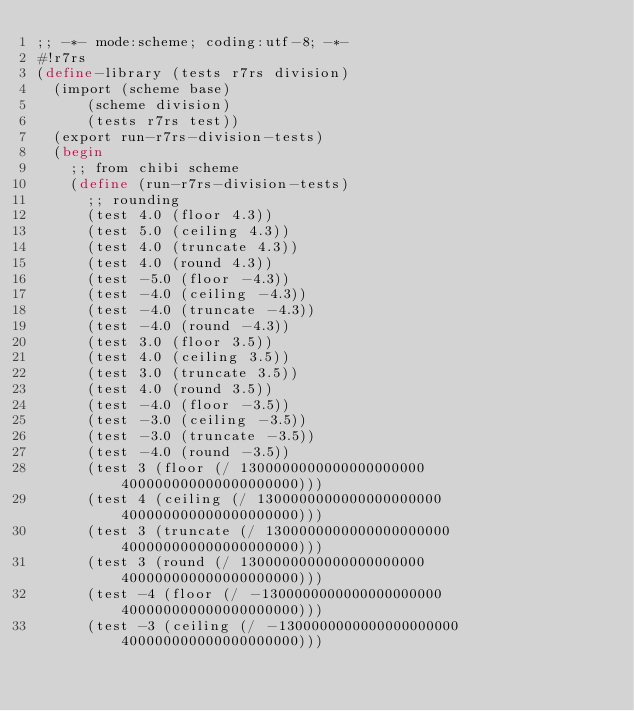Convert code to text. <code><loc_0><loc_0><loc_500><loc_500><_Scheme_>;; -*- mode:scheme; coding:utf-8; -*-
#!r7rs
(define-library (tests r7rs division)
  (import (scheme base)
	  (scheme division)
	  (tests r7rs test))
  (export run-r7rs-division-tests)
  (begin
    ;; from chibi scheme
    (define (run-r7rs-division-tests)
      ;; rounding
      (test 4.0 (floor 4.3))
      (test 5.0 (ceiling 4.3))
      (test 4.0 (truncate 4.3))
      (test 4.0 (round 4.3))
      (test -5.0 (floor -4.3))
      (test -4.0 (ceiling -4.3))
      (test -4.0 (truncate -4.3))
      (test -4.0 (round -4.3))
      (test 3.0 (floor 3.5)) 
      (test 4.0 (ceiling 3.5)) 
      (test 3.0 (truncate 3.5)) 
      (test 4.0 (round 3.5))
      (test -4.0 (floor -3.5)) 
      (test -3.0 (ceiling -3.5)) 
      (test -3.0 (truncate -3.5)) 
      (test -4.0 (round -3.5))
      (test 3 (floor (/ 1300000000000000000000 400000000000000000000)))
      (test 4 (ceiling (/ 1300000000000000000000 400000000000000000000)))
      (test 3 (truncate (/ 1300000000000000000000 400000000000000000000)))
      (test 3 (round (/ 1300000000000000000000 400000000000000000000)))
      (test -4 (floor (/ -1300000000000000000000 400000000000000000000)))
      (test -3 (ceiling (/ -1300000000000000000000 400000000000000000000)))</code> 